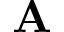<formula> <loc_0><loc_0><loc_500><loc_500>A</formula> 